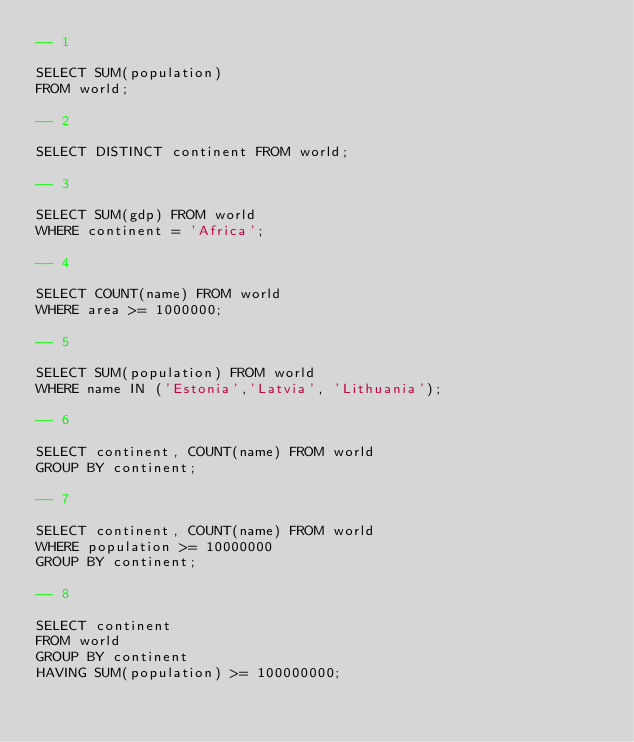<code> <loc_0><loc_0><loc_500><loc_500><_SQL_>-- 1

SELECT SUM(population)
FROM world;

-- 2

SELECT DISTINCT continent FROM world;

-- 3

SELECT SUM(gdp) FROM world
WHERE continent = 'Africa';

-- 4

SELECT COUNT(name) FROM world
WHERE area >= 1000000;

-- 5

SELECT SUM(population) FROM world
WHERE name IN ('Estonia','Latvia', 'Lithuania');

-- 6

SELECT continent, COUNT(name) FROM world
GROUP BY continent;

-- 7

SELECT continent, COUNT(name) FROM world
WHERE population >= 10000000
GROUP BY continent;

-- 8

SELECT continent 
FROM world
GROUP BY continent
HAVING SUM(population) >= 100000000;
</code> 